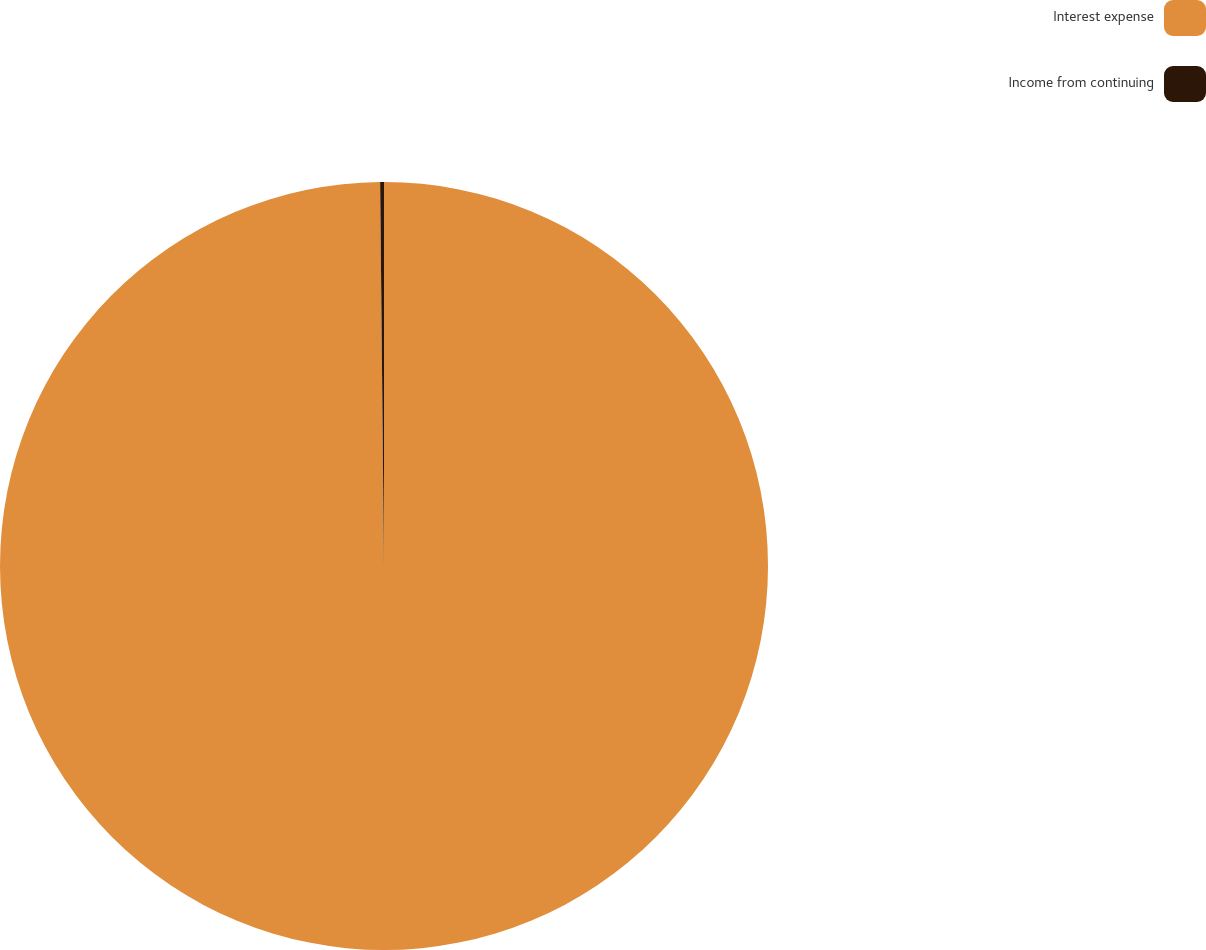Convert chart. <chart><loc_0><loc_0><loc_500><loc_500><pie_chart><fcel>Interest expense<fcel>Income from continuing<nl><fcel>99.84%<fcel>0.16%<nl></chart> 